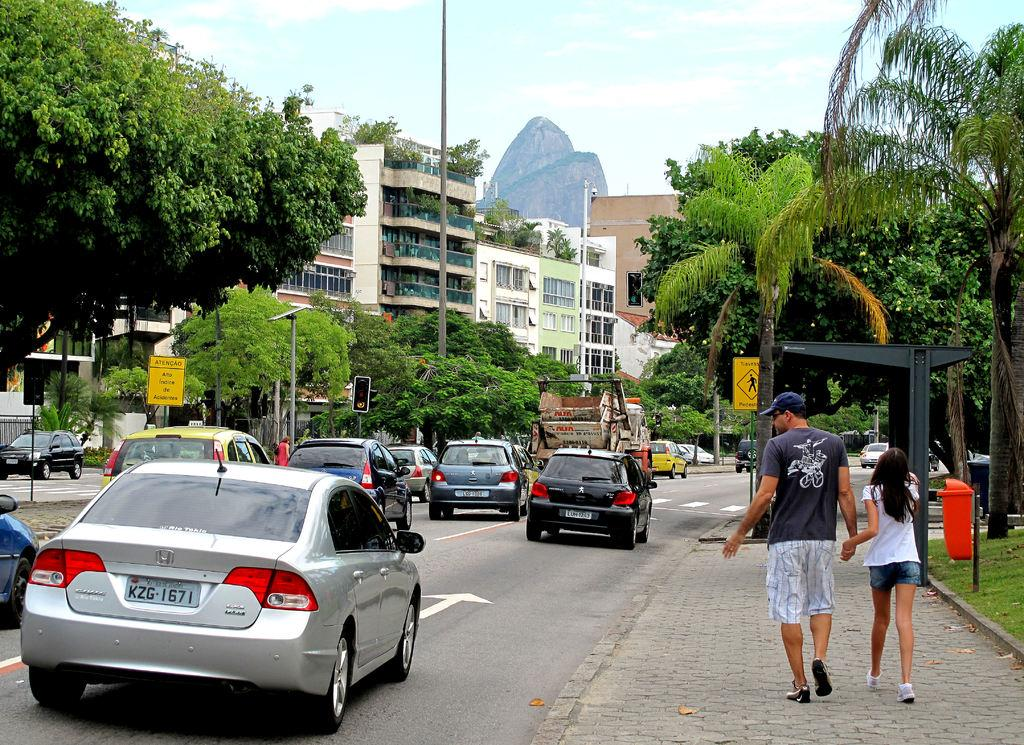What is happening on the road in the image? There are vehicles on the road in the image. What are the people in the image doing? There are people walking on a pathway in the image. What can be seen in the background of the image? There are poles, sign boards, trees, and buildings in the background of the image. What type of weather can be seen in the image? The provided facts do not mention any weather conditions, so we cannot determine the weather from the image. What type of dress is the station wearing in the image? There is no station or person wearing a dress present in the image. 